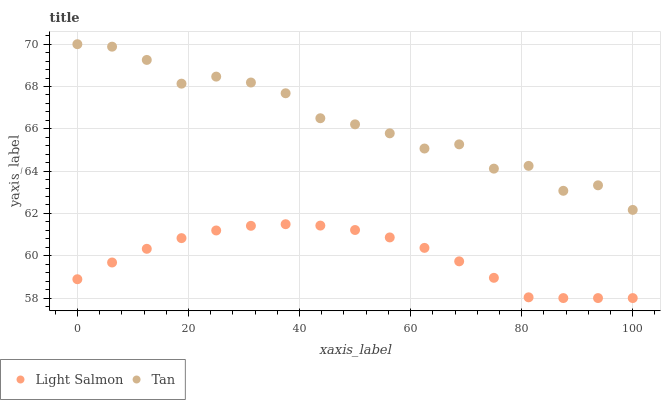Does Light Salmon have the minimum area under the curve?
Answer yes or no. Yes. Does Tan have the maximum area under the curve?
Answer yes or no. Yes. Does Tan have the minimum area under the curve?
Answer yes or no. No. Is Light Salmon the smoothest?
Answer yes or no. Yes. Is Tan the roughest?
Answer yes or no. Yes. Is Tan the smoothest?
Answer yes or no. No. Does Light Salmon have the lowest value?
Answer yes or no. Yes. Does Tan have the lowest value?
Answer yes or no. No. Does Tan have the highest value?
Answer yes or no. Yes. Is Light Salmon less than Tan?
Answer yes or no. Yes. Is Tan greater than Light Salmon?
Answer yes or no. Yes. Does Light Salmon intersect Tan?
Answer yes or no. No. 